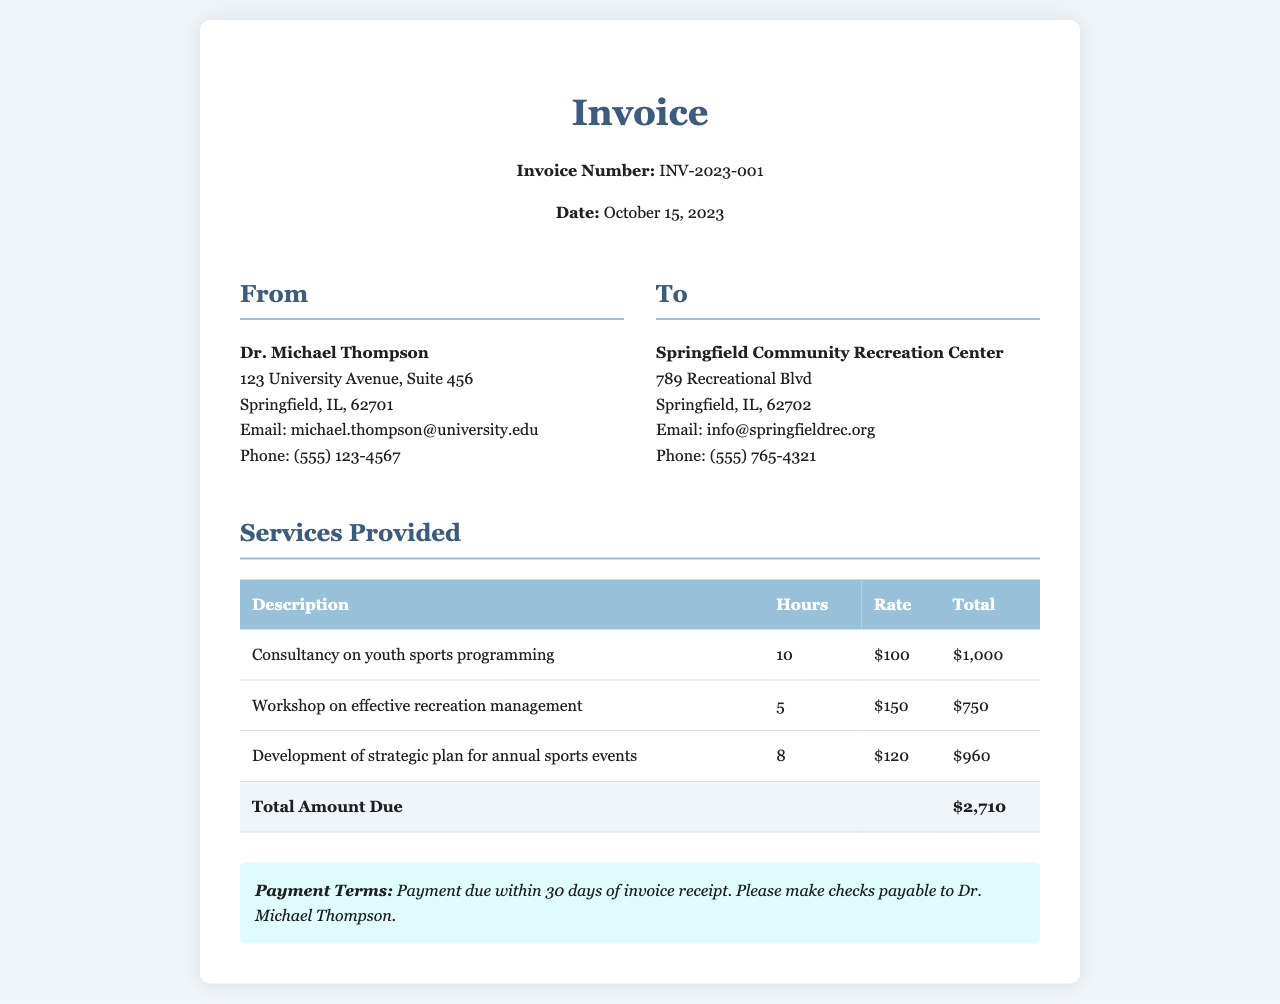what is the invoice number? The invoice number is listed prominently at the top of the document.
Answer: INV-2023-001 who is the consultant? The consultant's name and information are provided in the document's header.
Answer: Dr. Michael Thompson what is the date of the invoice? The date is stated near the invoice number in the document header.
Answer: October 15, 2023 how many hours were spent on youth sports programming consultancy? The hours for this service are specified in the services provided section of the invoice.
Answer: 10 what is the total amount due? The total amount due is indicated at the bottom of the services provided table.
Answer: $2,710 what is the payment term? The payment terms state the conditions under which payment is to be made.
Answer: Payment due within 30 days of invoice receipt how much was charged per hour for the workshop on effective recreation management? The rate for this service is provided in the table under the rate column.
Answer: $150 who is the client organization? The client's name and information are presented in the client info section of the document.
Answer: Springfield Community Recreation Center what is the total for the development of the strategic plan for annual sports events? The total for this service can be found in the corresponding row of the services provided table.
Answer: $960 